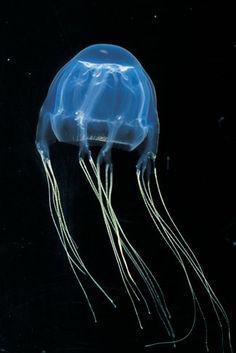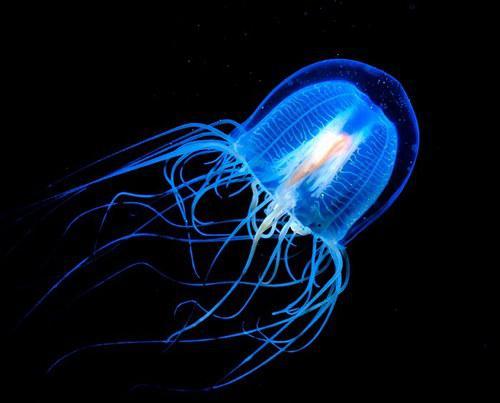The first image is the image on the left, the second image is the image on the right. For the images shown, is this caption "Both images show a single jellyfish with a black background." true? Answer yes or no. Yes. 